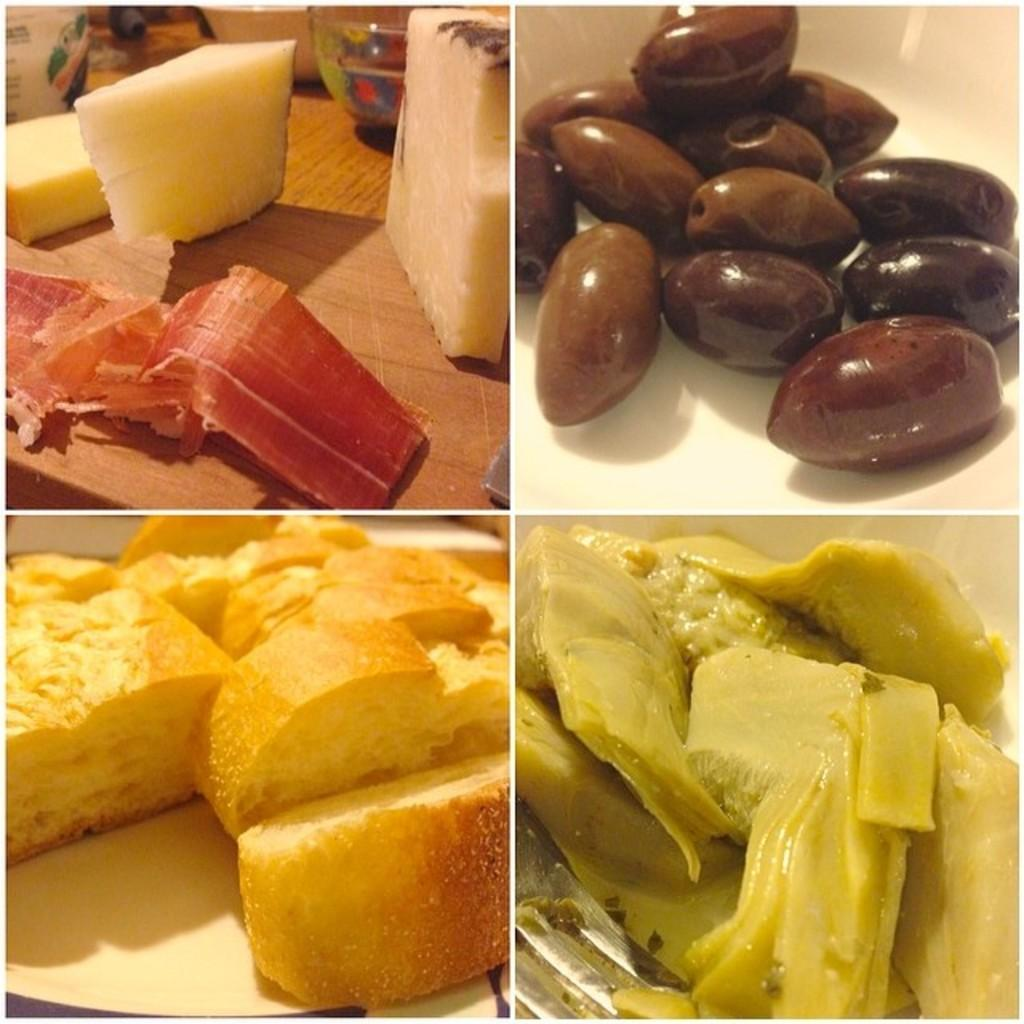What type of artwork is depicted in the image? The image is a collage. What can be seen within the collage? There are different varieties of foods in the collage. How are the foods arranged within the collage? The foods are displayed on different images within the collage. What type of summer activity is taking place in the image? There is no summer activity depicted in the image, as it is a collage of different foods. Can you describe the flight of the mouth in the image? There is no mouth or flight present in the image; it is a collage of different foods displayed on various images. 